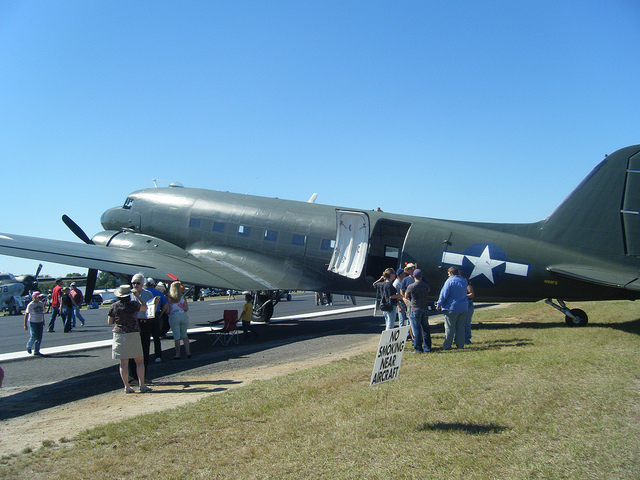<image>What is the oldest military plane that is still in use? I don't know what the oldest military plane that is still in use is. What shape is on the plane's tail? I am not sure about the exact shape on the plane's tail, it could be a star or a triangle. What is the oldest military plane that is still in use? I don't know what the oldest military plane that is still in use. It can be any of the mentioned options. What shape is on the plane's tail? I don't know what shape is on the plane's tail. It could be a star, triangle, or none. 